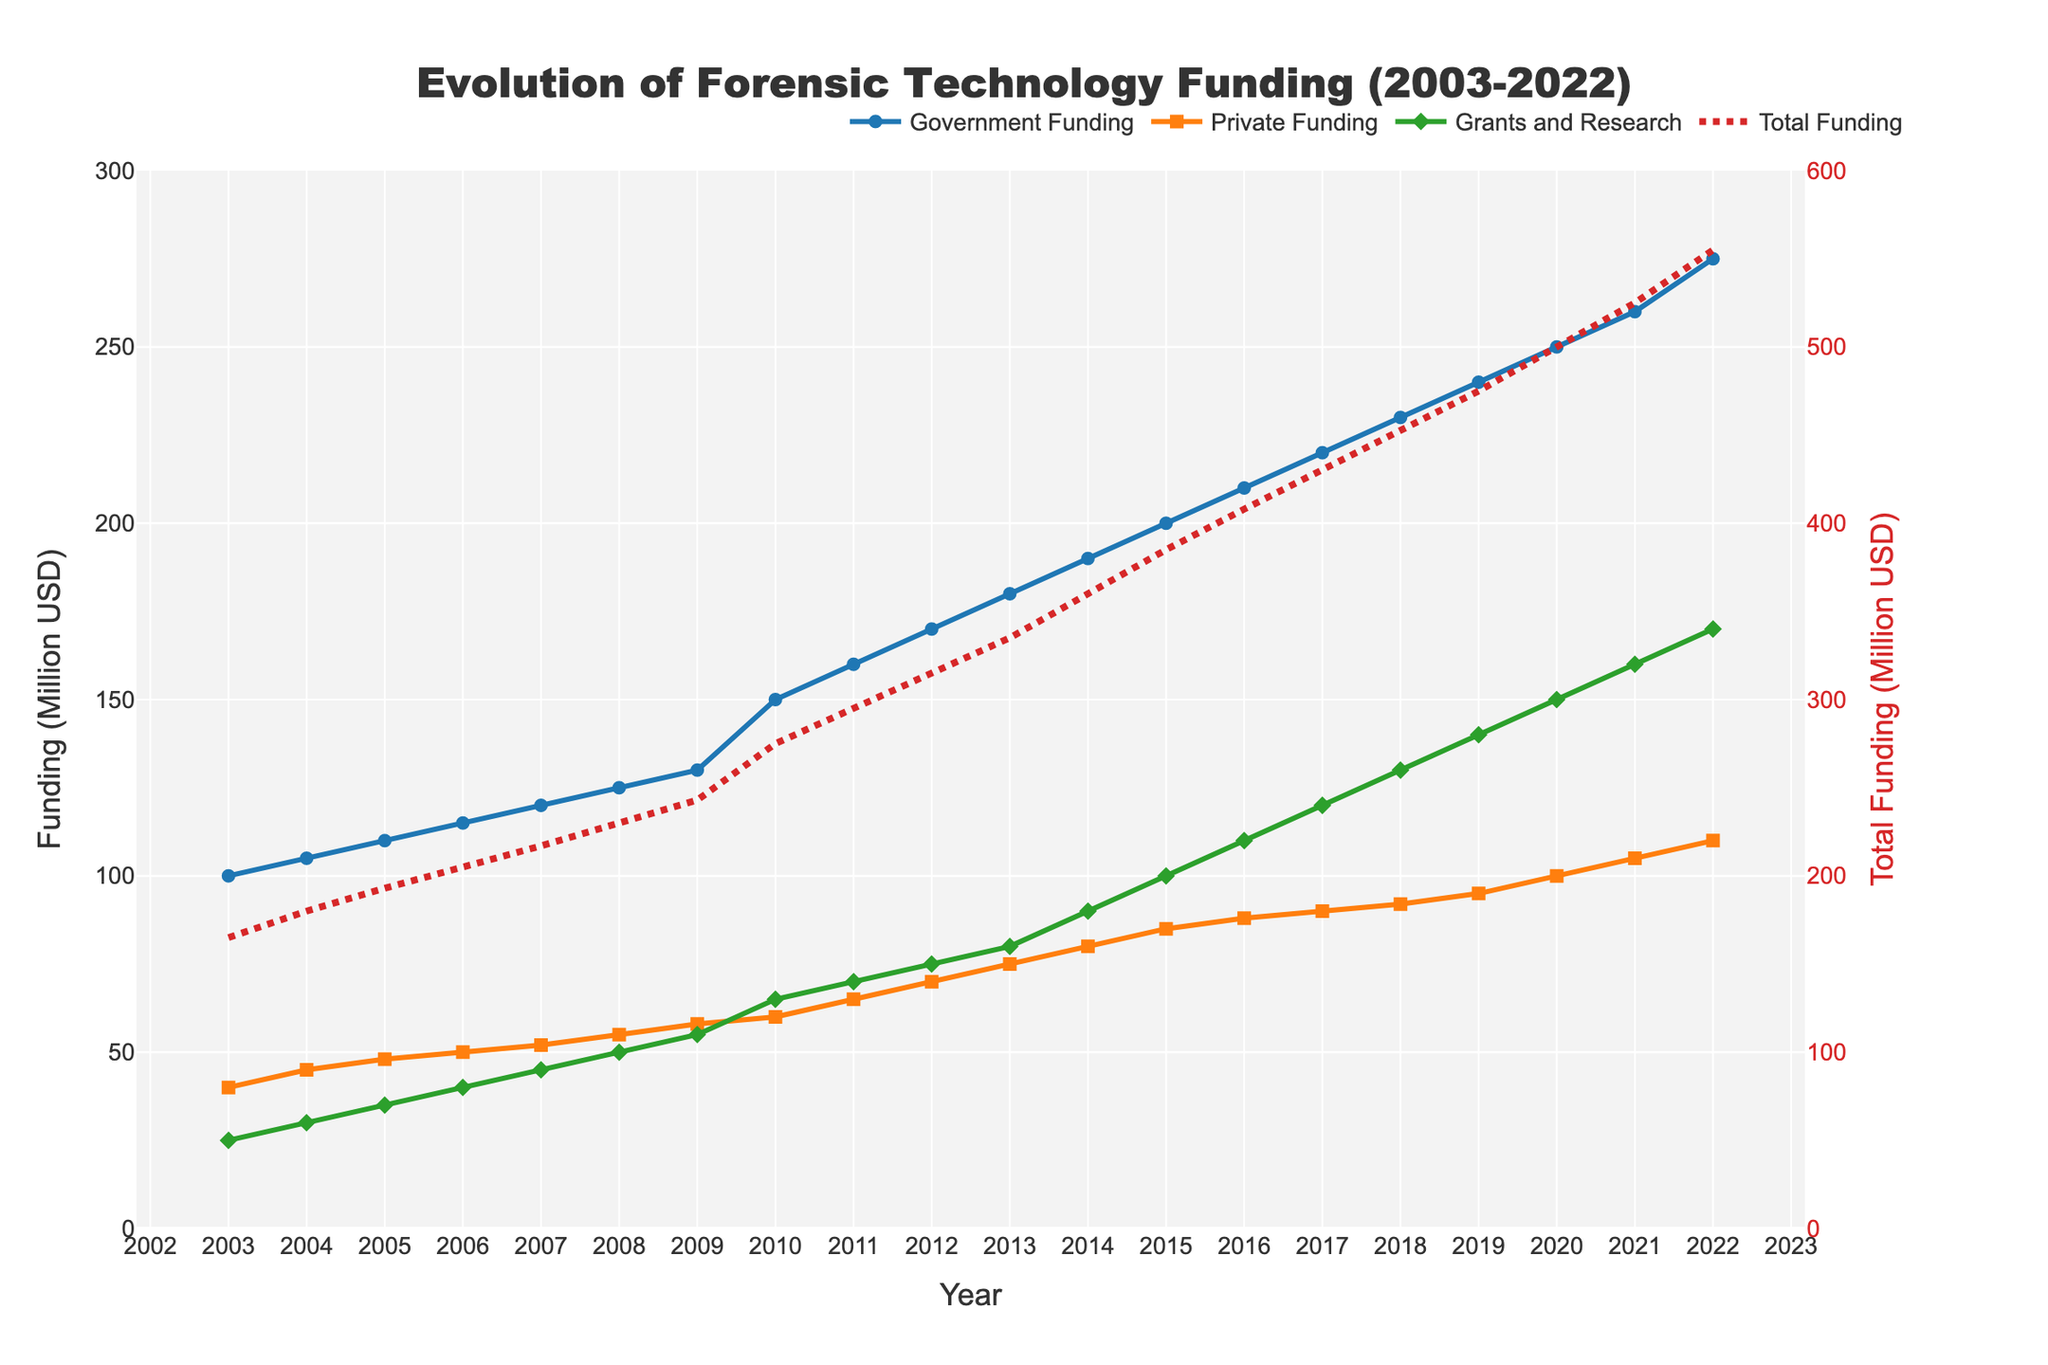What is the title of the plot? The title of the plot is displayed at the top center of the figure.
Answer: Evolution of Forensic Technology Funding (2003-2022) What is the total funding in 2010? Locate the year 2010 on the x-axis and refer to the "Total Funding (Million USD)" trace, which is represented by a dot-dashed star line.
Answer: 275 Million USD How has private funding changed from 2003 to 2022? Look at the "Private Funding (Million USD)" trace, which is represented by orange lines and squares, and compare the values for 2003 and 2022 on the y-axis.
Answer: Increased from 40 to 110 Million USD Which type of funding has the most significant increase over the years? Compare the trends of all funding types over the years by examining the slopes of the lines.
Answer: Government Funding When did grant and research funding reach 130 million USD for the first time? Identify the green diamond markers on the "Grants and Research Funding" trace, and find the year where the marker first crosses 130 on the y-axis.
Answer: 2018 Is there any year where government funding and private funding were equal? Compare the blue lines/circles and the orange lines/squares for the same years and see if they intersect.
Answer: No What is the average total funding between 2003 and 2007? Sum the "Total Funding (Million USD)" values for 2003-2007 and divide by 5: (165 + 180 + 193 + 205 + 217) / 5 = 960 / 5.
Answer: 192 Million USD Which year experienced the largest increase in total funding compared to the previous year? Examine the difference in "Total Funding (Million USD)" between consecutive years, focusing on the largest jump.
Answer: 2010 How does the trend of grants and research funding compare to that of private funding? Compare the overall slopes and relative increases over time for the green diamonds and orange squares traces.
Answer: Grants and research funding has a steeper slope, indicating a faster increase What are the colors used for each type of funding in the plot? Identify the colors of the lines/markers for each funding type.
Answer: Government: Blue, Private: Orange, Grants and Research: Green, Total: Red 